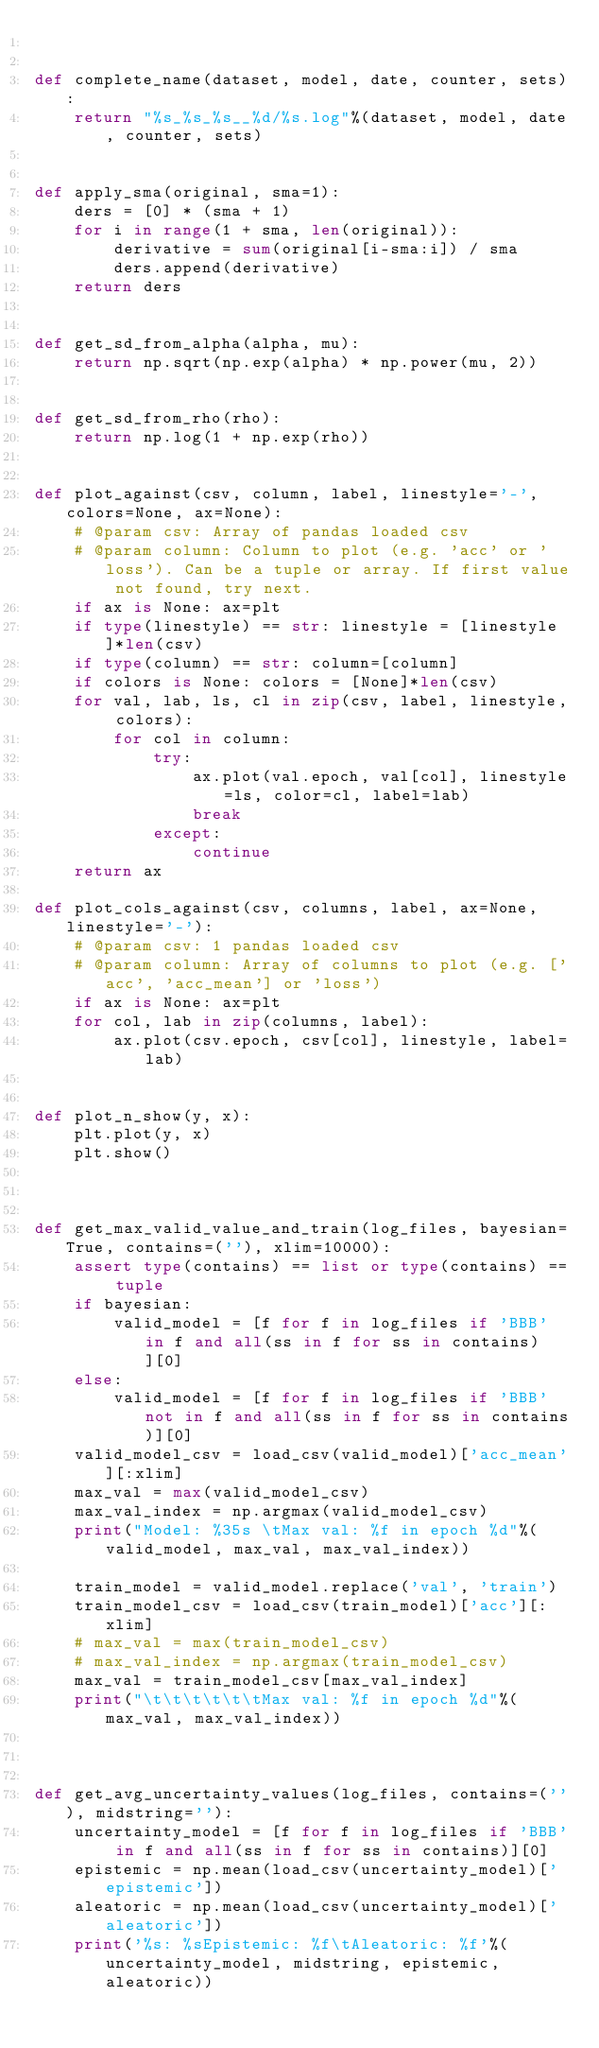<code> <loc_0><loc_0><loc_500><loc_500><_Python_>

def complete_name(dataset, model, date, counter, sets):
    return "%s_%s_%s__%d/%s.log"%(dataset, model, date, counter, sets)


def apply_sma(original, sma=1):
    ders = [0] * (sma + 1)
    for i in range(1 + sma, len(original)):
        derivative = sum(original[i-sma:i]) / sma
        ders.append(derivative)
    return ders


def get_sd_from_alpha(alpha, mu):
    return np.sqrt(np.exp(alpha) * np.power(mu, 2))


def get_sd_from_rho(rho):
    return np.log(1 + np.exp(rho))


def plot_against(csv, column, label, linestyle='-', colors=None, ax=None):
    # @param csv: Array of pandas loaded csv
    # @param column: Column to plot (e.g. 'acc' or 'loss'). Can be a tuple or array. If first value not found, try next.
    if ax is None: ax=plt
    if type(linestyle) == str: linestyle = [linestyle]*len(csv)
    if type(column) == str: column=[column]
    if colors is None: colors = [None]*len(csv)
    for val, lab, ls, cl in zip(csv, label, linestyle, colors):
        for col in column:
            try:
                ax.plot(val.epoch, val[col], linestyle=ls, color=cl, label=lab)
                break
            except:
                continue
    return ax

def plot_cols_against(csv, columns, label, ax=None, linestyle='-'):
    # @param csv: 1 pandas loaded csv
    # @param column: Array of columns to plot (e.g. ['acc', 'acc_mean'] or 'loss')
    if ax is None: ax=plt
    for col, lab in zip(columns, label):
        ax.plot(csv.epoch, csv[col], linestyle, label=lab)


def plot_n_show(y, x):
    plt.plot(y, x)
    plt.show()



def get_max_valid_value_and_train(log_files, bayesian=True, contains=(''), xlim=10000):
    assert type(contains) == list or type(contains) == tuple
    if bayesian:
        valid_model = [f for f in log_files if 'BBB' in f and all(ss in f for ss in contains)][0]
    else:
        valid_model = [f for f in log_files if 'BBB' not in f and all(ss in f for ss in contains)][0]
    valid_model_csv = load_csv(valid_model)['acc_mean'][:xlim]
    max_val = max(valid_model_csv)
    max_val_index = np.argmax(valid_model_csv)
    print("Model: %35s \tMax val: %f in epoch %d"%(valid_model, max_val, max_val_index))

    train_model = valid_model.replace('val', 'train')
    train_model_csv = load_csv(train_model)['acc'][:xlim]
    # max_val = max(train_model_csv)
    # max_val_index = np.argmax(train_model_csv)
    max_val = train_model_csv[max_val_index]
    print("\t\t\t\t\t\tMax val: %f in epoch %d"%(max_val, max_val_index))

    
    
def get_avg_uncertainty_values(log_files, contains=(''), midstring=''):
    uncertainty_model = [f for f in log_files if 'BBB' in f and all(ss in f for ss in contains)][0]
    epistemic = np.mean(load_csv(uncertainty_model)['epistemic'])
    aleatoric = np.mean(load_csv(uncertainty_model)['aleatoric'])
    print('%s: %sEpistemic: %f\tAleatoric: %f'%(uncertainty_model, midstring, epistemic, aleatoric))
</code> 